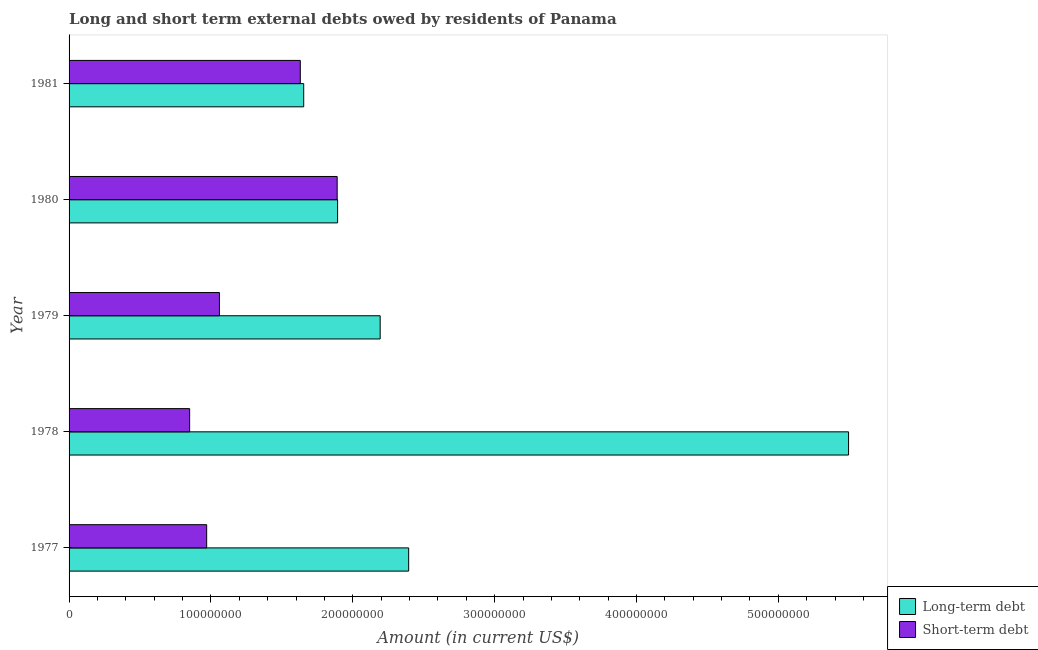How many different coloured bars are there?
Give a very brief answer. 2. How many groups of bars are there?
Your answer should be compact. 5. In how many cases, is the number of bars for a given year not equal to the number of legend labels?
Keep it short and to the point. 0. What is the short-term debts owed by residents in 1977?
Your answer should be compact. 9.70e+07. Across all years, what is the maximum short-term debts owed by residents?
Offer a terse response. 1.89e+08. Across all years, what is the minimum long-term debts owed by residents?
Your answer should be very brief. 1.65e+08. What is the total short-term debts owed by residents in the graph?
Provide a short and direct response. 6.40e+08. What is the difference between the long-term debts owed by residents in 1977 and that in 1978?
Provide a short and direct response. -3.10e+08. What is the difference between the long-term debts owed by residents in 1980 and the short-term debts owed by residents in 1977?
Offer a very short reply. 9.23e+07. What is the average short-term debts owed by residents per year?
Provide a short and direct response. 1.28e+08. In the year 1981, what is the difference between the long-term debts owed by residents and short-term debts owed by residents?
Keep it short and to the point. 2.40e+06. What is the ratio of the short-term debts owed by residents in 1978 to that in 1980?
Provide a short and direct response. 0.45. Is the difference between the long-term debts owed by residents in 1977 and 1980 greater than the difference between the short-term debts owed by residents in 1977 and 1980?
Ensure brevity in your answer.  Yes. What is the difference between the highest and the second highest long-term debts owed by residents?
Ensure brevity in your answer.  3.10e+08. What is the difference between the highest and the lowest long-term debts owed by residents?
Provide a succinct answer. 3.84e+08. In how many years, is the long-term debts owed by residents greater than the average long-term debts owed by residents taken over all years?
Offer a very short reply. 1. What does the 1st bar from the top in 1978 represents?
Offer a terse response. Short-term debt. What does the 1st bar from the bottom in 1980 represents?
Keep it short and to the point. Long-term debt. How many bars are there?
Your response must be concise. 10. How many years are there in the graph?
Give a very brief answer. 5. What is the difference between two consecutive major ticks on the X-axis?
Offer a very short reply. 1.00e+08. Does the graph contain any zero values?
Provide a short and direct response. No. Does the graph contain grids?
Offer a very short reply. No. How are the legend labels stacked?
Your answer should be compact. Vertical. What is the title of the graph?
Offer a very short reply. Long and short term external debts owed by residents of Panama. What is the label or title of the X-axis?
Provide a short and direct response. Amount (in current US$). What is the label or title of the Y-axis?
Offer a very short reply. Year. What is the Amount (in current US$) in Long-term debt in 1977?
Keep it short and to the point. 2.39e+08. What is the Amount (in current US$) of Short-term debt in 1977?
Offer a very short reply. 9.70e+07. What is the Amount (in current US$) of Long-term debt in 1978?
Offer a very short reply. 5.50e+08. What is the Amount (in current US$) in Short-term debt in 1978?
Ensure brevity in your answer.  8.50e+07. What is the Amount (in current US$) in Long-term debt in 1979?
Give a very brief answer. 2.19e+08. What is the Amount (in current US$) in Short-term debt in 1979?
Provide a succinct answer. 1.06e+08. What is the Amount (in current US$) in Long-term debt in 1980?
Make the answer very short. 1.89e+08. What is the Amount (in current US$) in Short-term debt in 1980?
Your answer should be compact. 1.89e+08. What is the Amount (in current US$) in Long-term debt in 1981?
Offer a terse response. 1.65e+08. What is the Amount (in current US$) of Short-term debt in 1981?
Your response must be concise. 1.63e+08. Across all years, what is the maximum Amount (in current US$) of Long-term debt?
Offer a very short reply. 5.50e+08. Across all years, what is the maximum Amount (in current US$) of Short-term debt?
Keep it short and to the point. 1.89e+08. Across all years, what is the minimum Amount (in current US$) in Long-term debt?
Provide a short and direct response. 1.65e+08. Across all years, what is the minimum Amount (in current US$) in Short-term debt?
Ensure brevity in your answer.  8.50e+07. What is the total Amount (in current US$) in Long-term debt in the graph?
Keep it short and to the point. 1.36e+09. What is the total Amount (in current US$) in Short-term debt in the graph?
Your answer should be very brief. 6.40e+08. What is the difference between the Amount (in current US$) of Long-term debt in 1977 and that in 1978?
Give a very brief answer. -3.10e+08. What is the difference between the Amount (in current US$) of Short-term debt in 1977 and that in 1978?
Your answer should be very brief. 1.20e+07. What is the difference between the Amount (in current US$) in Long-term debt in 1977 and that in 1979?
Offer a very short reply. 2.01e+07. What is the difference between the Amount (in current US$) of Short-term debt in 1977 and that in 1979?
Offer a terse response. -9.00e+06. What is the difference between the Amount (in current US$) of Long-term debt in 1977 and that in 1980?
Your response must be concise. 5.01e+07. What is the difference between the Amount (in current US$) of Short-term debt in 1977 and that in 1980?
Provide a succinct answer. -9.20e+07. What is the difference between the Amount (in current US$) of Long-term debt in 1977 and that in 1981?
Keep it short and to the point. 7.40e+07. What is the difference between the Amount (in current US$) in Short-term debt in 1977 and that in 1981?
Give a very brief answer. -6.60e+07. What is the difference between the Amount (in current US$) in Long-term debt in 1978 and that in 1979?
Make the answer very short. 3.30e+08. What is the difference between the Amount (in current US$) in Short-term debt in 1978 and that in 1979?
Your answer should be very brief. -2.10e+07. What is the difference between the Amount (in current US$) of Long-term debt in 1978 and that in 1980?
Your answer should be compact. 3.60e+08. What is the difference between the Amount (in current US$) in Short-term debt in 1978 and that in 1980?
Offer a very short reply. -1.04e+08. What is the difference between the Amount (in current US$) of Long-term debt in 1978 and that in 1981?
Make the answer very short. 3.84e+08. What is the difference between the Amount (in current US$) of Short-term debt in 1978 and that in 1981?
Offer a terse response. -7.80e+07. What is the difference between the Amount (in current US$) of Long-term debt in 1979 and that in 1980?
Provide a short and direct response. 3.00e+07. What is the difference between the Amount (in current US$) in Short-term debt in 1979 and that in 1980?
Give a very brief answer. -8.30e+07. What is the difference between the Amount (in current US$) of Long-term debt in 1979 and that in 1981?
Offer a very short reply. 5.39e+07. What is the difference between the Amount (in current US$) in Short-term debt in 1979 and that in 1981?
Ensure brevity in your answer.  -5.70e+07. What is the difference between the Amount (in current US$) of Long-term debt in 1980 and that in 1981?
Provide a short and direct response. 2.39e+07. What is the difference between the Amount (in current US$) in Short-term debt in 1980 and that in 1981?
Your response must be concise. 2.60e+07. What is the difference between the Amount (in current US$) in Long-term debt in 1977 and the Amount (in current US$) in Short-term debt in 1978?
Your answer should be very brief. 1.54e+08. What is the difference between the Amount (in current US$) in Long-term debt in 1977 and the Amount (in current US$) in Short-term debt in 1979?
Your answer should be compact. 1.33e+08. What is the difference between the Amount (in current US$) in Long-term debt in 1977 and the Amount (in current US$) in Short-term debt in 1980?
Provide a short and direct response. 5.04e+07. What is the difference between the Amount (in current US$) in Long-term debt in 1977 and the Amount (in current US$) in Short-term debt in 1981?
Keep it short and to the point. 7.64e+07. What is the difference between the Amount (in current US$) of Long-term debt in 1978 and the Amount (in current US$) of Short-term debt in 1979?
Offer a terse response. 4.44e+08. What is the difference between the Amount (in current US$) of Long-term debt in 1978 and the Amount (in current US$) of Short-term debt in 1980?
Offer a very short reply. 3.61e+08. What is the difference between the Amount (in current US$) in Long-term debt in 1978 and the Amount (in current US$) in Short-term debt in 1981?
Provide a short and direct response. 3.87e+08. What is the difference between the Amount (in current US$) of Long-term debt in 1979 and the Amount (in current US$) of Short-term debt in 1980?
Ensure brevity in your answer.  3.03e+07. What is the difference between the Amount (in current US$) of Long-term debt in 1979 and the Amount (in current US$) of Short-term debt in 1981?
Offer a very short reply. 5.63e+07. What is the difference between the Amount (in current US$) in Long-term debt in 1980 and the Amount (in current US$) in Short-term debt in 1981?
Your response must be concise. 2.63e+07. What is the average Amount (in current US$) of Long-term debt per year?
Give a very brief answer. 2.73e+08. What is the average Amount (in current US$) in Short-term debt per year?
Your answer should be very brief. 1.28e+08. In the year 1977, what is the difference between the Amount (in current US$) in Long-term debt and Amount (in current US$) in Short-term debt?
Provide a short and direct response. 1.42e+08. In the year 1978, what is the difference between the Amount (in current US$) of Long-term debt and Amount (in current US$) of Short-term debt?
Keep it short and to the point. 4.65e+08. In the year 1979, what is the difference between the Amount (in current US$) of Long-term debt and Amount (in current US$) of Short-term debt?
Give a very brief answer. 1.13e+08. In the year 1980, what is the difference between the Amount (in current US$) in Long-term debt and Amount (in current US$) in Short-term debt?
Offer a terse response. 2.95e+05. In the year 1981, what is the difference between the Amount (in current US$) in Long-term debt and Amount (in current US$) in Short-term debt?
Offer a terse response. 2.40e+06. What is the ratio of the Amount (in current US$) in Long-term debt in 1977 to that in 1978?
Your response must be concise. 0.44. What is the ratio of the Amount (in current US$) in Short-term debt in 1977 to that in 1978?
Provide a short and direct response. 1.14. What is the ratio of the Amount (in current US$) of Long-term debt in 1977 to that in 1979?
Offer a terse response. 1.09. What is the ratio of the Amount (in current US$) in Short-term debt in 1977 to that in 1979?
Ensure brevity in your answer.  0.92. What is the ratio of the Amount (in current US$) of Long-term debt in 1977 to that in 1980?
Your answer should be compact. 1.26. What is the ratio of the Amount (in current US$) of Short-term debt in 1977 to that in 1980?
Offer a very short reply. 0.51. What is the ratio of the Amount (in current US$) in Long-term debt in 1977 to that in 1981?
Keep it short and to the point. 1.45. What is the ratio of the Amount (in current US$) of Short-term debt in 1977 to that in 1981?
Ensure brevity in your answer.  0.6. What is the ratio of the Amount (in current US$) in Long-term debt in 1978 to that in 1979?
Make the answer very short. 2.51. What is the ratio of the Amount (in current US$) in Short-term debt in 1978 to that in 1979?
Your answer should be very brief. 0.8. What is the ratio of the Amount (in current US$) in Long-term debt in 1978 to that in 1980?
Give a very brief answer. 2.9. What is the ratio of the Amount (in current US$) of Short-term debt in 1978 to that in 1980?
Offer a very short reply. 0.45. What is the ratio of the Amount (in current US$) in Long-term debt in 1978 to that in 1981?
Offer a terse response. 3.32. What is the ratio of the Amount (in current US$) of Short-term debt in 1978 to that in 1981?
Your response must be concise. 0.52. What is the ratio of the Amount (in current US$) in Long-term debt in 1979 to that in 1980?
Give a very brief answer. 1.16. What is the ratio of the Amount (in current US$) of Short-term debt in 1979 to that in 1980?
Offer a very short reply. 0.56. What is the ratio of the Amount (in current US$) in Long-term debt in 1979 to that in 1981?
Ensure brevity in your answer.  1.33. What is the ratio of the Amount (in current US$) of Short-term debt in 1979 to that in 1981?
Provide a succinct answer. 0.65. What is the ratio of the Amount (in current US$) of Long-term debt in 1980 to that in 1981?
Keep it short and to the point. 1.14. What is the ratio of the Amount (in current US$) in Short-term debt in 1980 to that in 1981?
Provide a succinct answer. 1.16. What is the difference between the highest and the second highest Amount (in current US$) of Long-term debt?
Your answer should be compact. 3.10e+08. What is the difference between the highest and the second highest Amount (in current US$) in Short-term debt?
Provide a short and direct response. 2.60e+07. What is the difference between the highest and the lowest Amount (in current US$) of Long-term debt?
Offer a very short reply. 3.84e+08. What is the difference between the highest and the lowest Amount (in current US$) in Short-term debt?
Offer a very short reply. 1.04e+08. 